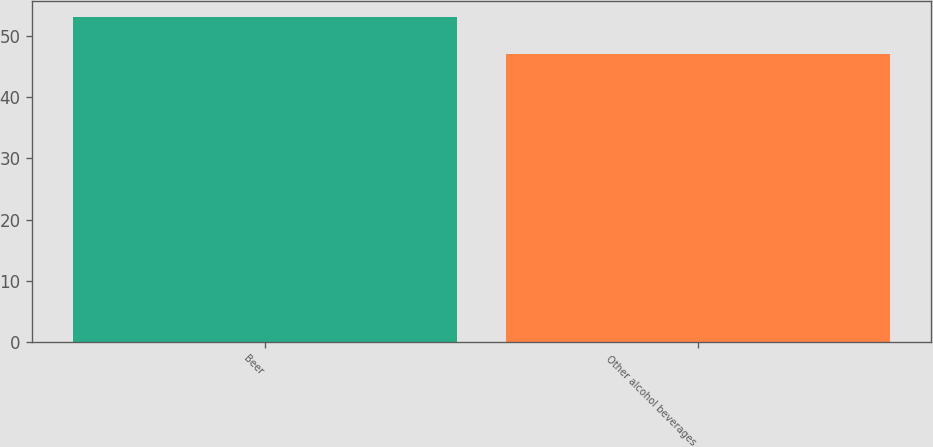<chart> <loc_0><loc_0><loc_500><loc_500><bar_chart><fcel>Beer<fcel>Other alcohol beverages<nl><fcel>53<fcel>47<nl></chart> 